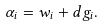<formula> <loc_0><loc_0><loc_500><loc_500>\alpha _ { i } = w _ { i } + d g _ { i } .</formula> 